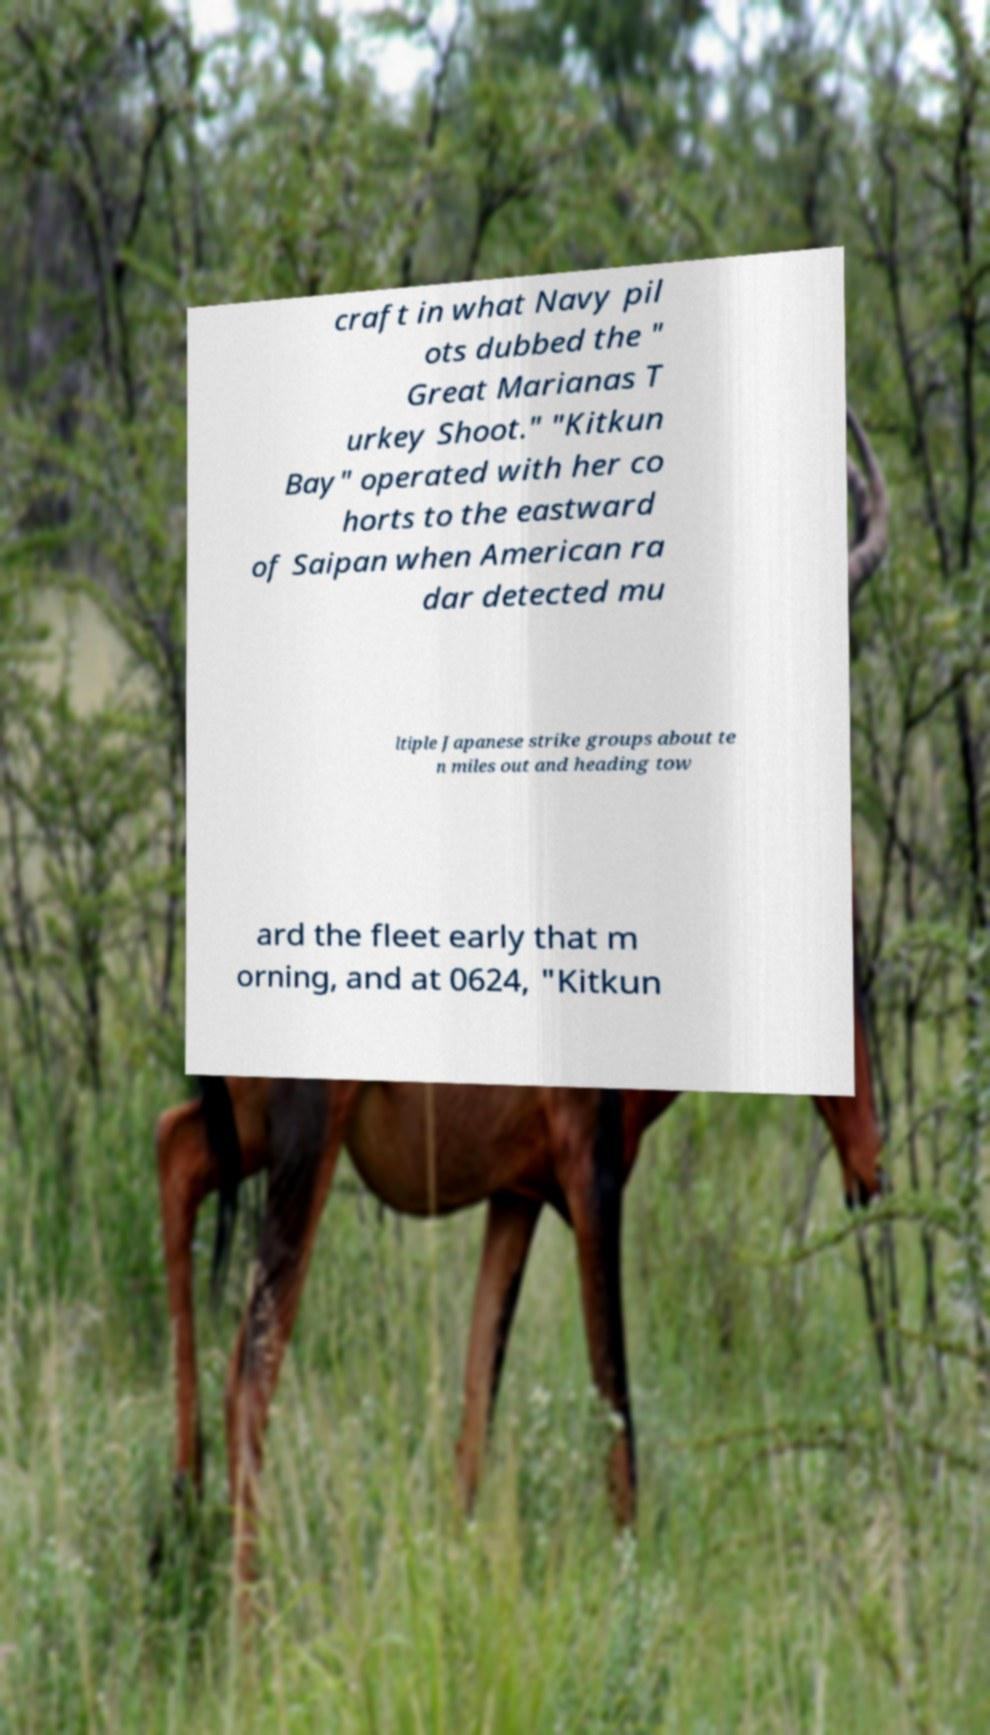There's text embedded in this image that I need extracted. Can you transcribe it verbatim? craft in what Navy pil ots dubbed the " Great Marianas T urkey Shoot." "Kitkun Bay" operated with her co horts to the eastward of Saipan when American ra dar detected mu ltiple Japanese strike groups about te n miles out and heading tow ard the fleet early that m orning, and at 0624, "Kitkun 